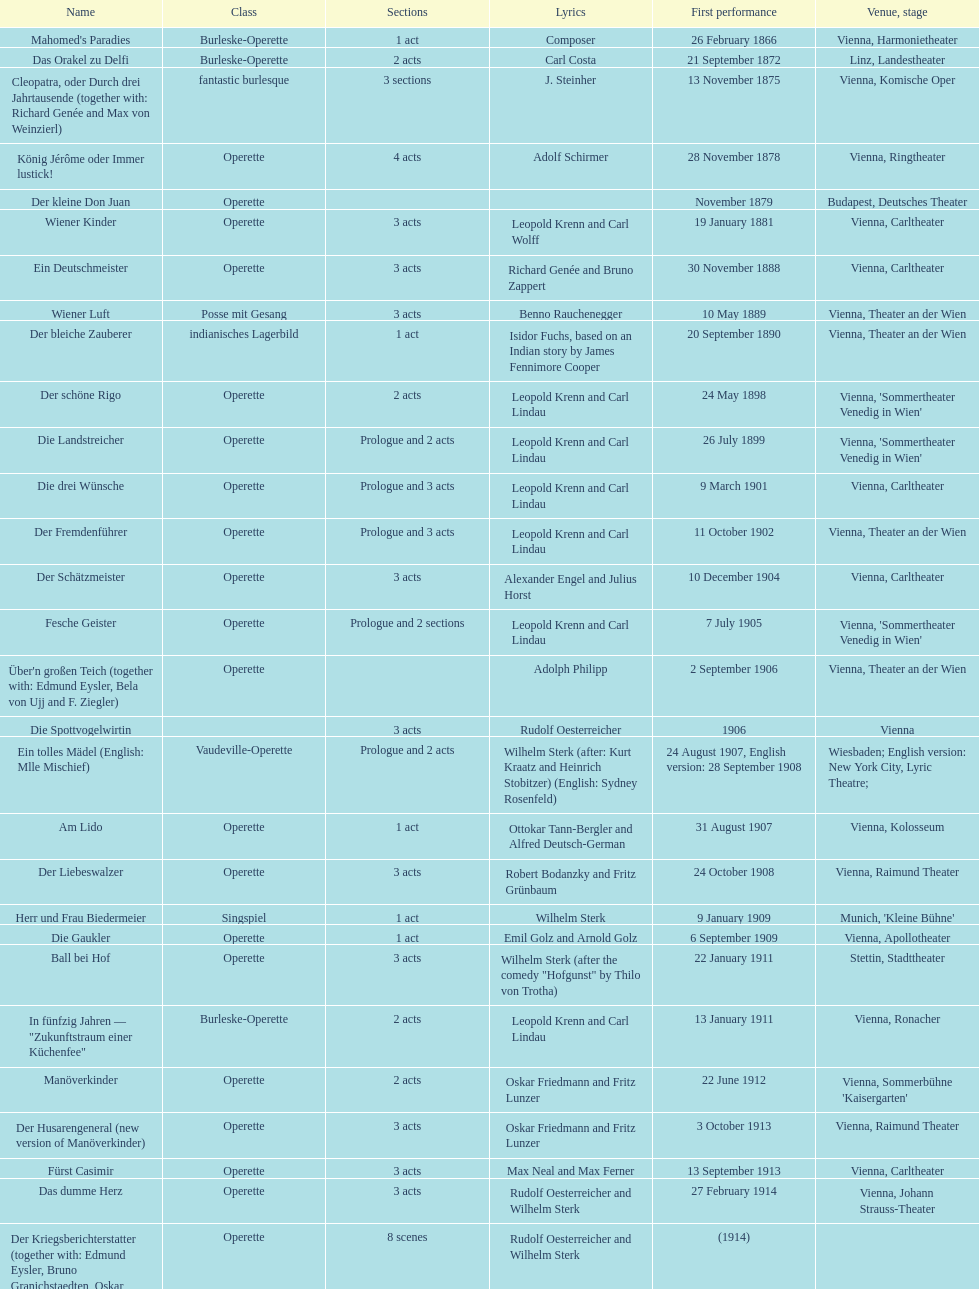Help me parse the entirety of this table. {'header': ['Name', 'Class', 'Sections', 'Lyrics', 'First performance', 'Venue, stage'], 'rows': [["Mahomed's Paradies", 'Burleske-Operette', '1 act', 'Composer', '26 February 1866', 'Vienna, Harmonietheater'], ['Das Orakel zu Delfi', 'Burleske-Operette', '2 acts', 'Carl Costa', '21 September 1872', 'Linz, Landestheater'], ['Cleopatra, oder Durch drei Jahrtausende (together with: Richard Genée and Max von Weinzierl)', 'fantastic burlesque', '3 sections', 'J. Steinher', '13 November 1875', 'Vienna, Komische Oper'], ['König Jérôme oder Immer lustick!', 'Operette', '4 acts', 'Adolf Schirmer', '28 November 1878', 'Vienna, Ringtheater'], ['Der kleine Don Juan', 'Operette', '', '', 'November 1879', 'Budapest, Deutsches Theater'], ['Wiener Kinder', 'Operette', '3 acts', 'Leopold Krenn and Carl Wolff', '19 January 1881', 'Vienna, Carltheater'], ['Ein Deutschmeister', 'Operette', '3 acts', 'Richard Genée and Bruno Zappert', '30 November 1888', 'Vienna, Carltheater'], ['Wiener Luft', 'Posse mit Gesang', '3 acts', 'Benno Rauchenegger', '10 May 1889', 'Vienna, Theater an der Wien'], ['Der bleiche Zauberer', 'indianisches Lagerbild', '1 act', 'Isidor Fuchs, based on an Indian story by James Fennimore Cooper', '20 September 1890', 'Vienna, Theater an der Wien'], ['Der schöne Rigo', 'Operette', '2 acts', 'Leopold Krenn and Carl Lindau', '24 May 1898', "Vienna, 'Sommertheater Venedig in Wien'"], ['Die Landstreicher', 'Operette', 'Prologue and 2 acts', 'Leopold Krenn and Carl Lindau', '26 July 1899', "Vienna, 'Sommertheater Venedig in Wien'"], ['Die drei Wünsche', 'Operette', 'Prologue and 3 acts', 'Leopold Krenn and Carl Lindau', '9 March 1901', 'Vienna, Carltheater'], ['Der Fremdenführer', 'Operette', 'Prologue and 3 acts', 'Leopold Krenn and Carl Lindau', '11 October 1902', 'Vienna, Theater an der Wien'], ['Der Schätzmeister', 'Operette', '3 acts', 'Alexander Engel and Julius Horst', '10 December 1904', 'Vienna, Carltheater'], ['Fesche Geister', 'Operette', 'Prologue and 2 sections', 'Leopold Krenn and Carl Lindau', '7 July 1905', "Vienna, 'Sommertheater Venedig in Wien'"], ["Über'n großen Teich (together with: Edmund Eysler, Bela von Ujj and F. Ziegler)", 'Operette', '', 'Adolph Philipp', '2 September 1906', 'Vienna, Theater an der Wien'], ['Die Spottvogelwirtin', '', '3 acts', 'Rudolf Oesterreicher', '1906', 'Vienna'], ['Ein tolles Mädel (English: Mlle Mischief)', 'Vaudeville-Operette', 'Prologue and 2 acts', 'Wilhelm Sterk (after: Kurt Kraatz and Heinrich Stobitzer) (English: Sydney Rosenfeld)', '24 August 1907, English version: 28 September 1908', 'Wiesbaden; English version: New York City, Lyric Theatre;'], ['Am Lido', 'Operette', '1 act', 'Ottokar Tann-Bergler and Alfred Deutsch-German', '31 August 1907', 'Vienna, Kolosseum'], ['Der Liebeswalzer', 'Operette', '3 acts', 'Robert Bodanzky and Fritz Grünbaum', '24 October 1908', 'Vienna, Raimund Theater'], ['Herr und Frau Biedermeier', 'Singspiel', '1 act', 'Wilhelm Sterk', '9 January 1909', "Munich, 'Kleine Bühne'"], ['Die Gaukler', 'Operette', '1 act', 'Emil Golz and Arnold Golz', '6 September 1909', 'Vienna, Apollotheater'], ['Ball bei Hof', 'Operette', '3 acts', 'Wilhelm Sterk (after the comedy "Hofgunst" by Thilo von Trotha)', '22 January 1911', 'Stettin, Stadttheater'], ['In fünfzig Jahren — "Zukunftstraum einer Küchenfee"', 'Burleske-Operette', '2 acts', 'Leopold Krenn and Carl Lindau', '13 January 1911', 'Vienna, Ronacher'], ['Manöverkinder', 'Operette', '2 acts', 'Oskar Friedmann and Fritz Lunzer', '22 June 1912', "Vienna, Sommerbühne 'Kaisergarten'"], ['Der Husarengeneral (new version of Manöverkinder)', 'Operette', '3 acts', 'Oskar Friedmann and Fritz Lunzer', '3 October 1913', 'Vienna, Raimund Theater'], ['Fürst Casimir', 'Operette', '3 acts', 'Max Neal and Max Ferner', '13 September 1913', 'Vienna, Carltheater'], ['Das dumme Herz', 'Operette', '3 acts', 'Rudolf Oesterreicher and Wilhelm Sterk', '27 February 1914', 'Vienna, Johann Strauss-Theater'], ['Der Kriegsberichterstatter (together with: Edmund Eysler, Bruno Granichstaedten, Oskar Nedbal, Charles Weinberger)', 'Operette', '8 scenes', 'Rudolf Oesterreicher and Wilhelm Sterk', '(1914)', ''], ['Im siebenten Himmel', 'Operette', '3 acts', 'Max Neal and Max Ferner', '26 February 1916', 'Munich, Theater am Gärtnerplatz'], ['Deutschmeisterkapelle', 'Operette', '', 'Hubert Marischka and Rudolf Oesterreicher', '30 May 1958', 'Vienna, Raimund Theater'], ['Die verliebte Eskadron', 'Operette', '3 acts', 'Wilhelm Sterk (after B. Buchbinder)', '11 July 1930', 'Vienna, Johann-Strauß-Theater']]} How many number of 1 acts were there? 5. 